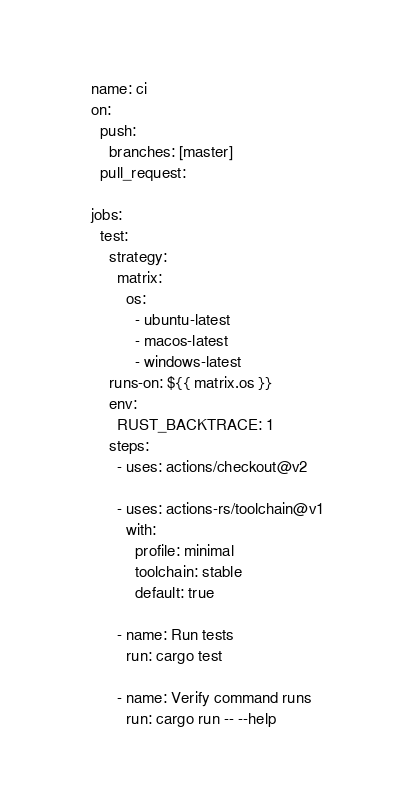<code> <loc_0><loc_0><loc_500><loc_500><_YAML_>name: ci
on:
  push:
    branches: [master]
  pull_request:

jobs:
  test:
    strategy:
      matrix:
        os:
          - ubuntu-latest
          - macos-latest
          - windows-latest
    runs-on: ${{ matrix.os }}
    env:
      RUST_BACKTRACE: 1
    steps:
      - uses: actions/checkout@v2

      - uses: actions-rs/toolchain@v1
        with:
          profile: minimal
          toolchain: stable
          default: true

      - name: Run tests
        run: cargo test

      - name: Verify command runs
        run: cargo run -- --help
</code> 